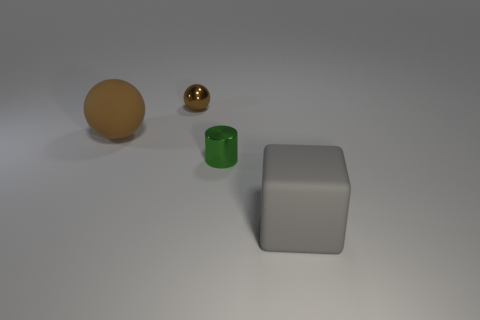What number of other things are the same shape as the large brown matte thing?
Provide a short and direct response. 1. Is there a shiny sphere that is left of the ball that is to the left of the small brown metallic object?
Your answer should be very brief. No. How many brown spheres are there?
Ensure brevity in your answer.  2. There is a small shiny sphere; is it the same color as the object on the right side of the cylinder?
Provide a succinct answer. No. Are there more big gray matte cubes than large objects?
Make the answer very short. No. Is there any other thing of the same color as the large ball?
Your answer should be very brief. Yes. How many other things are there of the same size as the brown metal thing?
Offer a very short reply. 1. What material is the small object that is in front of the ball that is in front of the tiny metal thing that is behind the green shiny object?
Provide a succinct answer. Metal. Do the green cylinder and the brown object in front of the brown metal ball have the same material?
Provide a succinct answer. No. Is the number of brown balls on the right side of the tiny brown metallic thing less than the number of large matte objects in front of the tiny shiny cylinder?
Provide a short and direct response. Yes. 